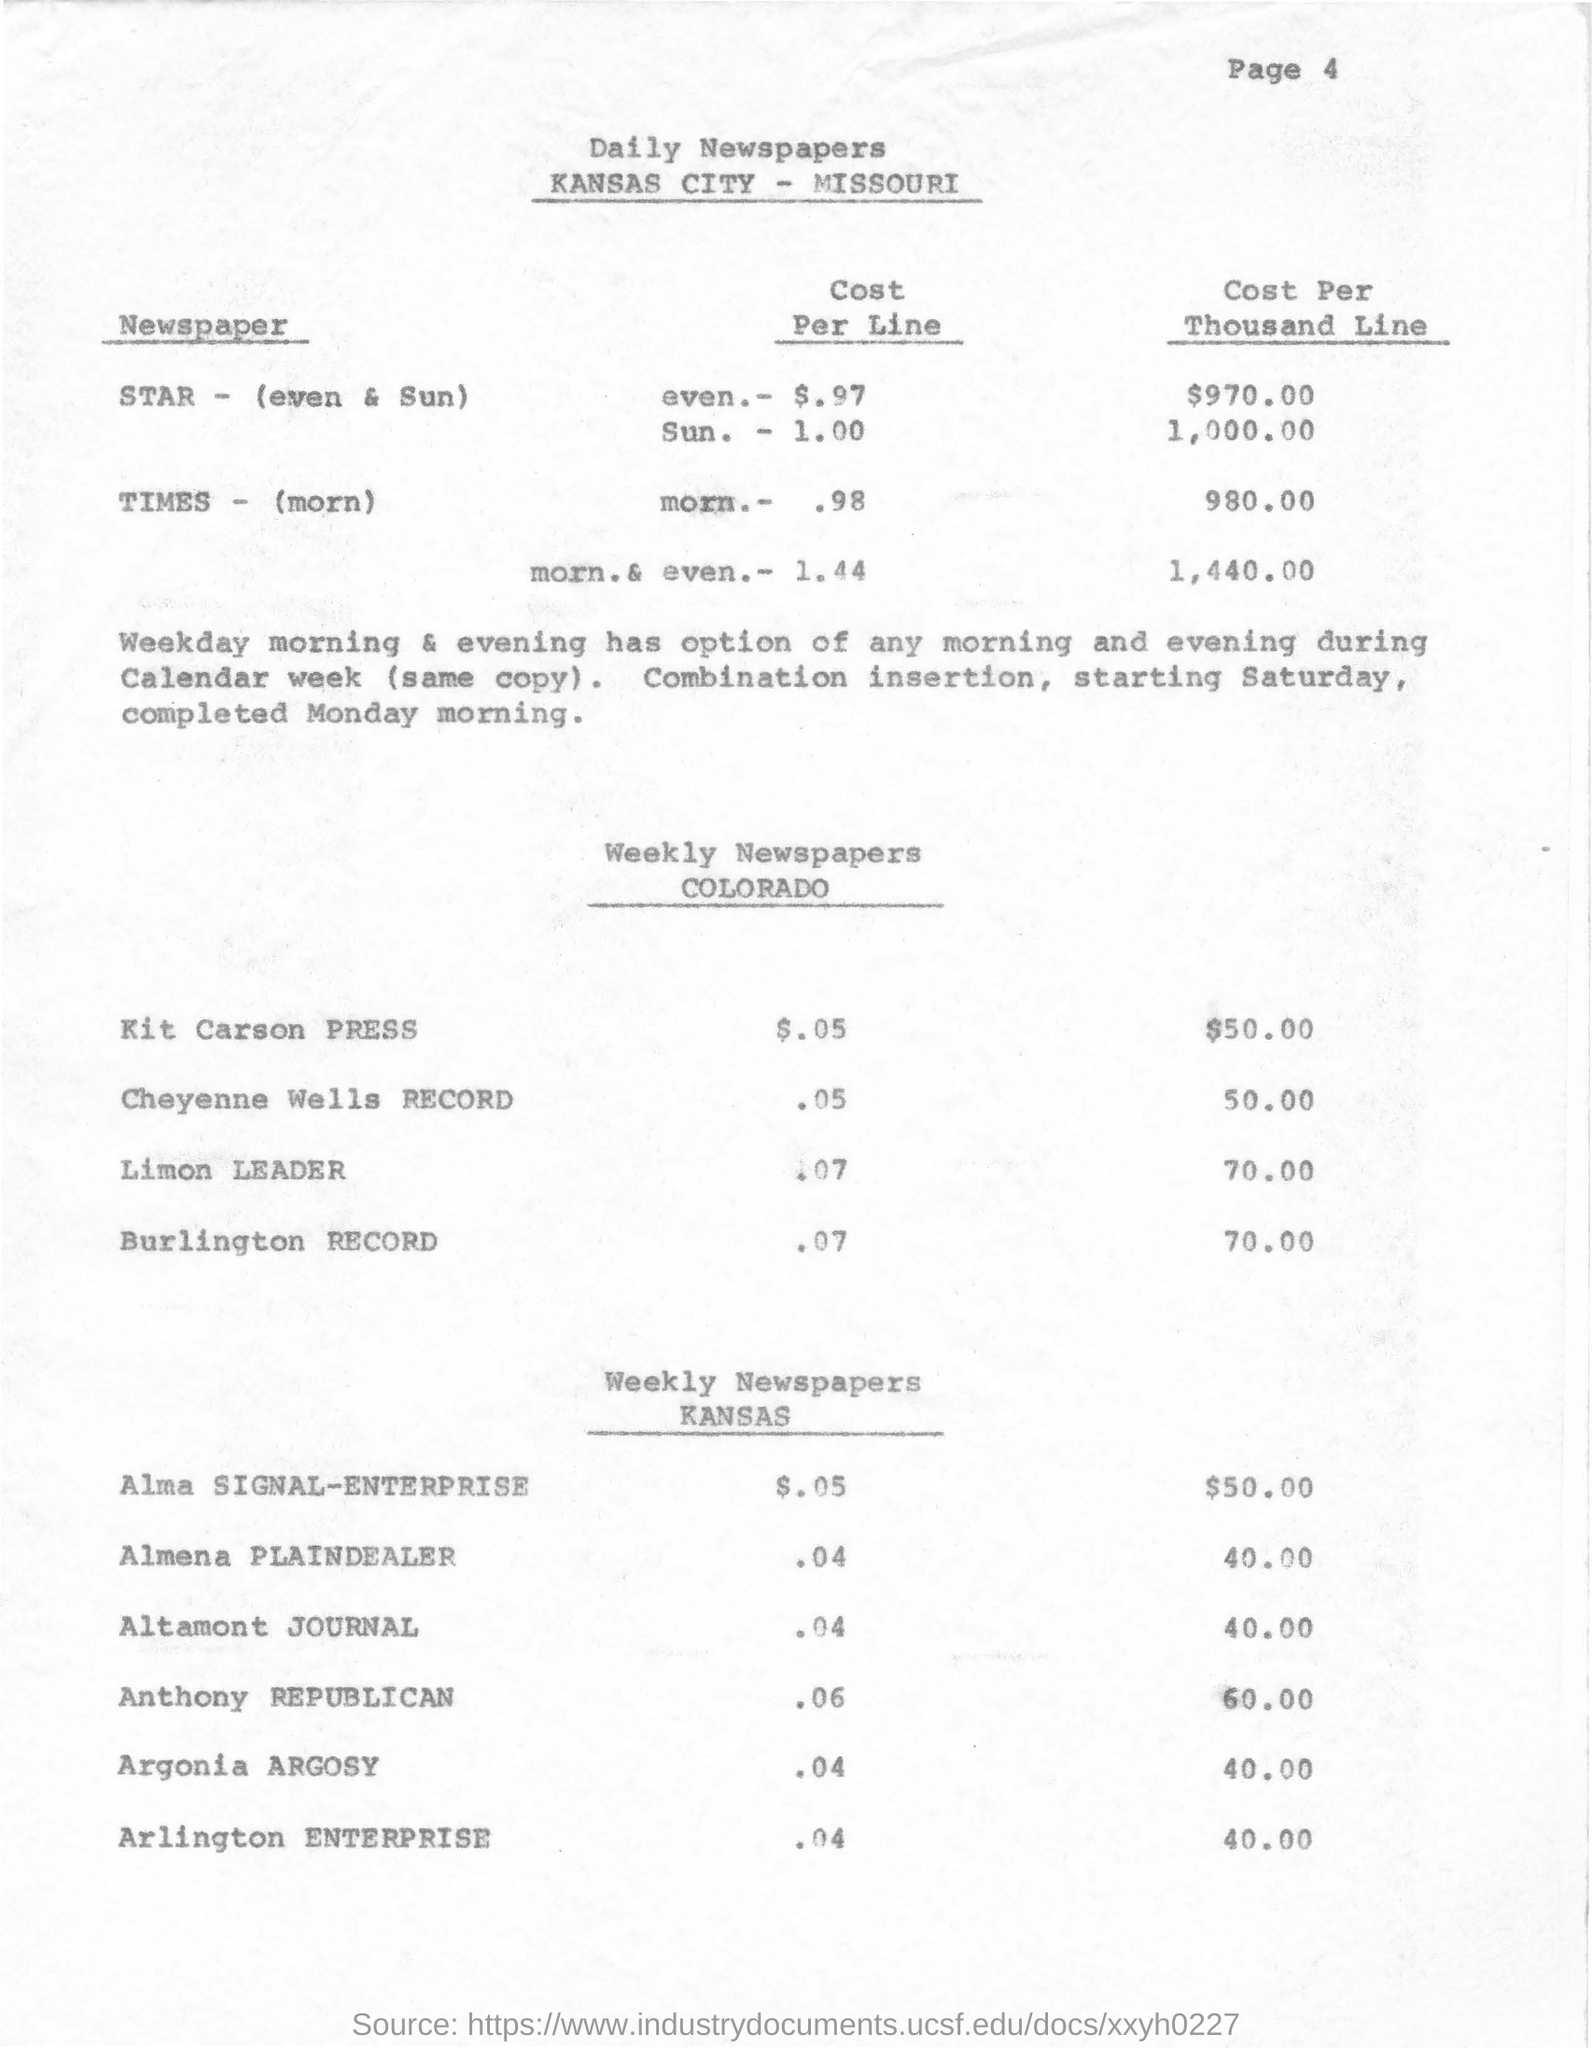Outline some significant characteristics in this image. The city mentioned in the document is Kansas. The cost per thousand lines for Anthony Republican in Kansas is 60.00. The cost per line for Kit Carson Press is $0.05. 